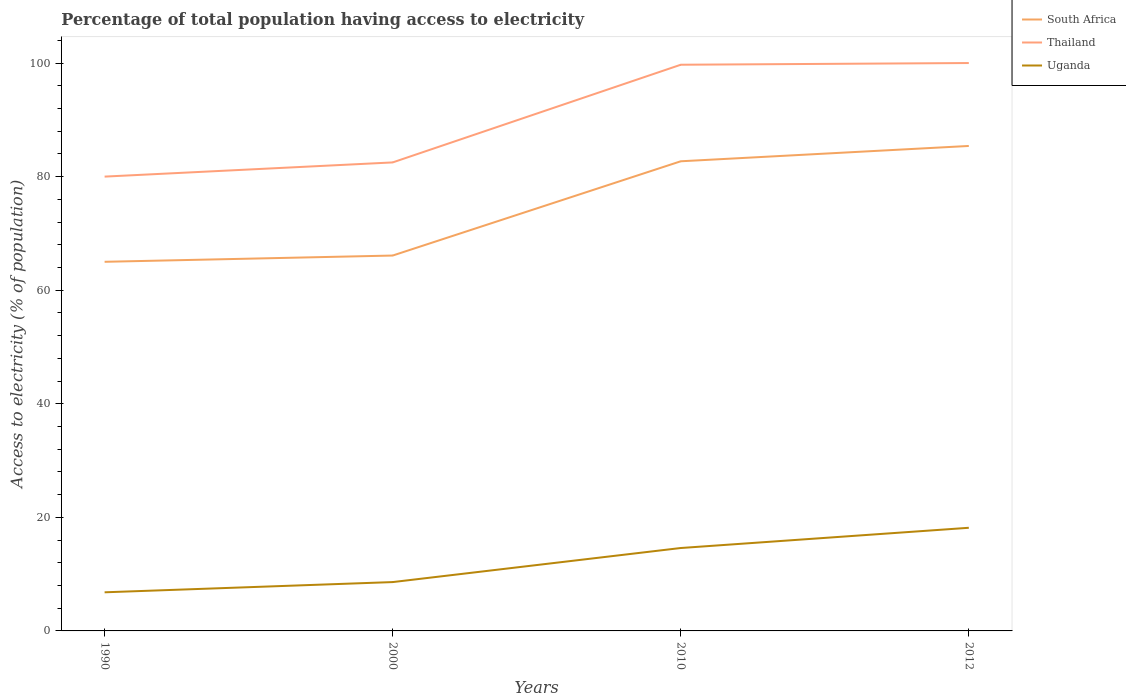Does the line corresponding to Thailand intersect with the line corresponding to Uganda?
Your response must be concise. No. Across all years, what is the maximum percentage of population that have access to electricity in Uganda?
Offer a terse response. 6.8. What is the total percentage of population that have access to electricity in South Africa in the graph?
Keep it short and to the point. -19.3. What is the difference between the highest and the lowest percentage of population that have access to electricity in Thailand?
Your response must be concise. 2. How many lines are there?
Give a very brief answer. 3. How many years are there in the graph?
Provide a short and direct response. 4. Does the graph contain any zero values?
Provide a succinct answer. No. Does the graph contain grids?
Provide a short and direct response. No. What is the title of the graph?
Your answer should be very brief. Percentage of total population having access to electricity. What is the label or title of the X-axis?
Give a very brief answer. Years. What is the label or title of the Y-axis?
Keep it short and to the point. Access to electricity (% of population). What is the Access to electricity (% of population) of South Africa in 1990?
Make the answer very short. 65. What is the Access to electricity (% of population) of Thailand in 1990?
Your answer should be compact. 80. What is the Access to electricity (% of population) in South Africa in 2000?
Keep it short and to the point. 66.1. What is the Access to electricity (% of population) in Thailand in 2000?
Offer a terse response. 82.5. What is the Access to electricity (% of population) in South Africa in 2010?
Provide a succinct answer. 82.7. What is the Access to electricity (% of population) in Thailand in 2010?
Give a very brief answer. 99.7. What is the Access to electricity (% of population) of South Africa in 2012?
Offer a terse response. 85.4. What is the Access to electricity (% of population) in Thailand in 2012?
Your answer should be very brief. 100. What is the Access to electricity (% of population) in Uganda in 2012?
Keep it short and to the point. 18.16. Across all years, what is the maximum Access to electricity (% of population) of South Africa?
Provide a succinct answer. 85.4. Across all years, what is the maximum Access to electricity (% of population) in Uganda?
Provide a short and direct response. 18.16. Across all years, what is the minimum Access to electricity (% of population) of South Africa?
Provide a succinct answer. 65. What is the total Access to electricity (% of population) of South Africa in the graph?
Provide a short and direct response. 299.2. What is the total Access to electricity (% of population) of Thailand in the graph?
Provide a succinct answer. 362.2. What is the total Access to electricity (% of population) in Uganda in the graph?
Offer a very short reply. 48.16. What is the difference between the Access to electricity (% of population) in South Africa in 1990 and that in 2000?
Your answer should be compact. -1.1. What is the difference between the Access to electricity (% of population) of Thailand in 1990 and that in 2000?
Your response must be concise. -2.5. What is the difference between the Access to electricity (% of population) of Uganda in 1990 and that in 2000?
Provide a short and direct response. -1.8. What is the difference between the Access to electricity (% of population) of South Africa in 1990 and that in 2010?
Ensure brevity in your answer.  -17.7. What is the difference between the Access to electricity (% of population) of Thailand in 1990 and that in 2010?
Give a very brief answer. -19.7. What is the difference between the Access to electricity (% of population) in Uganda in 1990 and that in 2010?
Your response must be concise. -7.8. What is the difference between the Access to electricity (% of population) in South Africa in 1990 and that in 2012?
Provide a succinct answer. -20.4. What is the difference between the Access to electricity (% of population) in Thailand in 1990 and that in 2012?
Provide a succinct answer. -20. What is the difference between the Access to electricity (% of population) of Uganda in 1990 and that in 2012?
Provide a short and direct response. -11.36. What is the difference between the Access to electricity (% of population) in South Africa in 2000 and that in 2010?
Your answer should be very brief. -16.6. What is the difference between the Access to electricity (% of population) of Thailand in 2000 and that in 2010?
Your response must be concise. -17.2. What is the difference between the Access to electricity (% of population) in Uganda in 2000 and that in 2010?
Ensure brevity in your answer.  -6. What is the difference between the Access to electricity (% of population) in South Africa in 2000 and that in 2012?
Your response must be concise. -19.3. What is the difference between the Access to electricity (% of population) in Thailand in 2000 and that in 2012?
Make the answer very short. -17.5. What is the difference between the Access to electricity (% of population) of Uganda in 2000 and that in 2012?
Make the answer very short. -9.56. What is the difference between the Access to electricity (% of population) in Uganda in 2010 and that in 2012?
Your response must be concise. -3.56. What is the difference between the Access to electricity (% of population) in South Africa in 1990 and the Access to electricity (% of population) in Thailand in 2000?
Your response must be concise. -17.5. What is the difference between the Access to electricity (% of population) in South Africa in 1990 and the Access to electricity (% of population) in Uganda in 2000?
Give a very brief answer. 56.4. What is the difference between the Access to electricity (% of population) in Thailand in 1990 and the Access to electricity (% of population) in Uganda in 2000?
Offer a very short reply. 71.4. What is the difference between the Access to electricity (% of population) in South Africa in 1990 and the Access to electricity (% of population) in Thailand in 2010?
Your answer should be very brief. -34.7. What is the difference between the Access to electricity (% of population) in South Africa in 1990 and the Access to electricity (% of population) in Uganda in 2010?
Provide a succinct answer. 50.4. What is the difference between the Access to electricity (% of population) of Thailand in 1990 and the Access to electricity (% of population) of Uganda in 2010?
Your answer should be compact. 65.4. What is the difference between the Access to electricity (% of population) in South Africa in 1990 and the Access to electricity (% of population) in Thailand in 2012?
Ensure brevity in your answer.  -35. What is the difference between the Access to electricity (% of population) of South Africa in 1990 and the Access to electricity (% of population) of Uganda in 2012?
Offer a terse response. 46.84. What is the difference between the Access to electricity (% of population) of Thailand in 1990 and the Access to electricity (% of population) of Uganda in 2012?
Give a very brief answer. 61.84. What is the difference between the Access to electricity (% of population) of South Africa in 2000 and the Access to electricity (% of population) of Thailand in 2010?
Ensure brevity in your answer.  -33.6. What is the difference between the Access to electricity (% of population) of South Africa in 2000 and the Access to electricity (% of population) of Uganda in 2010?
Give a very brief answer. 51.5. What is the difference between the Access to electricity (% of population) in Thailand in 2000 and the Access to electricity (% of population) in Uganda in 2010?
Your answer should be very brief. 67.9. What is the difference between the Access to electricity (% of population) in South Africa in 2000 and the Access to electricity (% of population) in Thailand in 2012?
Keep it short and to the point. -33.9. What is the difference between the Access to electricity (% of population) of South Africa in 2000 and the Access to electricity (% of population) of Uganda in 2012?
Keep it short and to the point. 47.94. What is the difference between the Access to electricity (% of population) of Thailand in 2000 and the Access to electricity (% of population) of Uganda in 2012?
Make the answer very short. 64.34. What is the difference between the Access to electricity (% of population) in South Africa in 2010 and the Access to electricity (% of population) in Thailand in 2012?
Make the answer very short. -17.3. What is the difference between the Access to electricity (% of population) of South Africa in 2010 and the Access to electricity (% of population) of Uganda in 2012?
Ensure brevity in your answer.  64.54. What is the difference between the Access to electricity (% of population) of Thailand in 2010 and the Access to electricity (% of population) of Uganda in 2012?
Provide a succinct answer. 81.54. What is the average Access to electricity (% of population) of South Africa per year?
Ensure brevity in your answer.  74.8. What is the average Access to electricity (% of population) of Thailand per year?
Keep it short and to the point. 90.55. What is the average Access to electricity (% of population) in Uganda per year?
Give a very brief answer. 12.04. In the year 1990, what is the difference between the Access to electricity (% of population) in South Africa and Access to electricity (% of population) in Uganda?
Your answer should be very brief. 58.2. In the year 1990, what is the difference between the Access to electricity (% of population) of Thailand and Access to electricity (% of population) of Uganda?
Offer a very short reply. 73.2. In the year 2000, what is the difference between the Access to electricity (% of population) of South Africa and Access to electricity (% of population) of Thailand?
Your response must be concise. -16.4. In the year 2000, what is the difference between the Access to electricity (% of population) in South Africa and Access to electricity (% of population) in Uganda?
Your response must be concise. 57.5. In the year 2000, what is the difference between the Access to electricity (% of population) in Thailand and Access to electricity (% of population) in Uganda?
Ensure brevity in your answer.  73.9. In the year 2010, what is the difference between the Access to electricity (% of population) of South Africa and Access to electricity (% of population) of Uganda?
Give a very brief answer. 68.1. In the year 2010, what is the difference between the Access to electricity (% of population) in Thailand and Access to electricity (% of population) in Uganda?
Ensure brevity in your answer.  85.1. In the year 2012, what is the difference between the Access to electricity (% of population) in South Africa and Access to electricity (% of population) in Thailand?
Your answer should be very brief. -14.6. In the year 2012, what is the difference between the Access to electricity (% of population) of South Africa and Access to electricity (% of population) of Uganda?
Your response must be concise. 67.24. In the year 2012, what is the difference between the Access to electricity (% of population) of Thailand and Access to electricity (% of population) of Uganda?
Keep it short and to the point. 81.84. What is the ratio of the Access to electricity (% of population) in South Africa in 1990 to that in 2000?
Offer a terse response. 0.98. What is the ratio of the Access to electricity (% of population) in Thailand in 1990 to that in 2000?
Offer a terse response. 0.97. What is the ratio of the Access to electricity (% of population) in Uganda in 1990 to that in 2000?
Keep it short and to the point. 0.79. What is the ratio of the Access to electricity (% of population) of South Africa in 1990 to that in 2010?
Provide a succinct answer. 0.79. What is the ratio of the Access to electricity (% of population) of Thailand in 1990 to that in 2010?
Ensure brevity in your answer.  0.8. What is the ratio of the Access to electricity (% of population) of Uganda in 1990 to that in 2010?
Keep it short and to the point. 0.47. What is the ratio of the Access to electricity (% of population) of South Africa in 1990 to that in 2012?
Your response must be concise. 0.76. What is the ratio of the Access to electricity (% of population) of Uganda in 1990 to that in 2012?
Offer a terse response. 0.37. What is the ratio of the Access to electricity (% of population) of South Africa in 2000 to that in 2010?
Your response must be concise. 0.8. What is the ratio of the Access to electricity (% of population) of Thailand in 2000 to that in 2010?
Keep it short and to the point. 0.83. What is the ratio of the Access to electricity (% of population) of Uganda in 2000 to that in 2010?
Ensure brevity in your answer.  0.59. What is the ratio of the Access to electricity (% of population) of South Africa in 2000 to that in 2012?
Give a very brief answer. 0.77. What is the ratio of the Access to electricity (% of population) in Thailand in 2000 to that in 2012?
Provide a succinct answer. 0.82. What is the ratio of the Access to electricity (% of population) of Uganda in 2000 to that in 2012?
Give a very brief answer. 0.47. What is the ratio of the Access to electricity (% of population) of South Africa in 2010 to that in 2012?
Provide a short and direct response. 0.97. What is the ratio of the Access to electricity (% of population) in Uganda in 2010 to that in 2012?
Give a very brief answer. 0.8. What is the difference between the highest and the second highest Access to electricity (% of population) in Uganda?
Make the answer very short. 3.56. What is the difference between the highest and the lowest Access to electricity (% of population) of South Africa?
Give a very brief answer. 20.4. What is the difference between the highest and the lowest Access to electricity (% of population) of Uganda?
Offer a terse response. 11.36. 